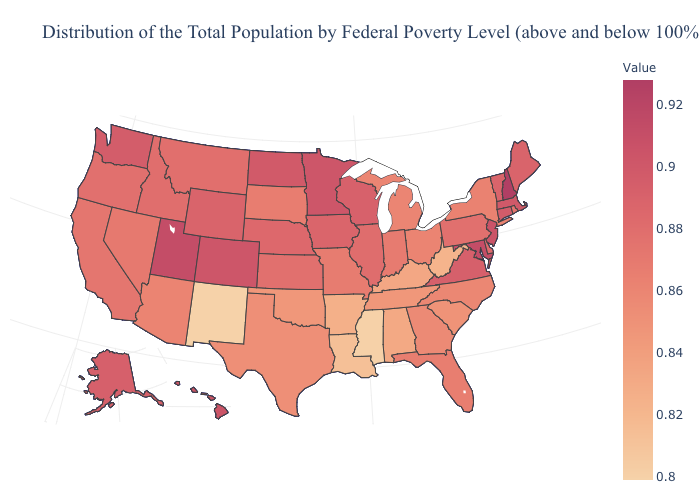Is the legend a continuous bar?
Concise answer only. Yes. Is the legend a continuous bar?
Short answer required. Yes. Does the map have missing data?
Give a very brief answer. No. Does Mississippi have the lowest value in the South?
Write a very short answer. Yes. Is the legend a continuous bar?
Be succinct. Yes. 